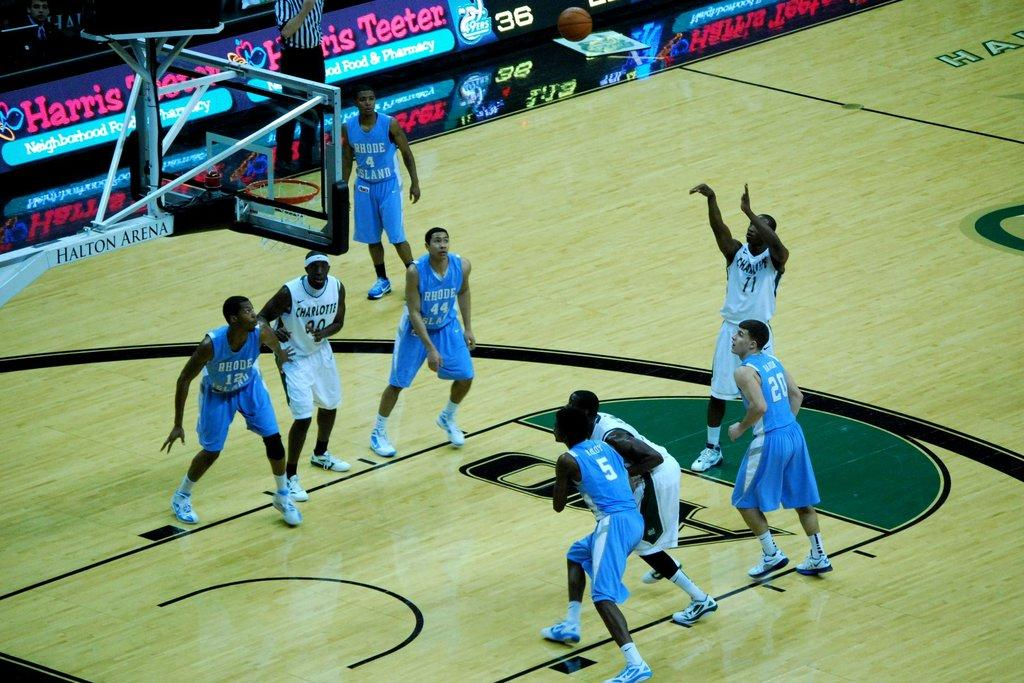What are the people in the image wearing? The people in the image are wearing blue and white color dresses. What can be seen in the background of the image? There is a basketball goal post in the image. What is the main object associated with the basketball goal post? There is a basketball in the image. What other objects are present in the image? There are colorful boards in the image. What type of tin is being used to play basketball in the image? There is no tin present in the image; it features a basketball goal post and a basketball. 